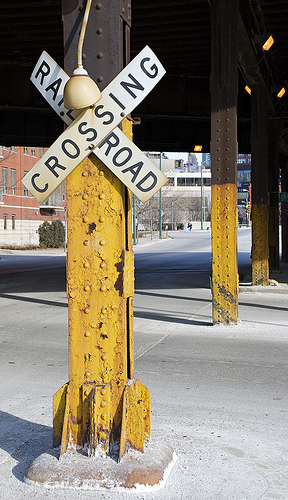<image>How many trains pass by this railroad crossing? It is ambiguous to tell how many trains pass by this railroad crossing. How many trains pass by this railroad crossing? I am not sure how many trains pass by this railroad crossing. It can be either 0 or 1 or 2. 